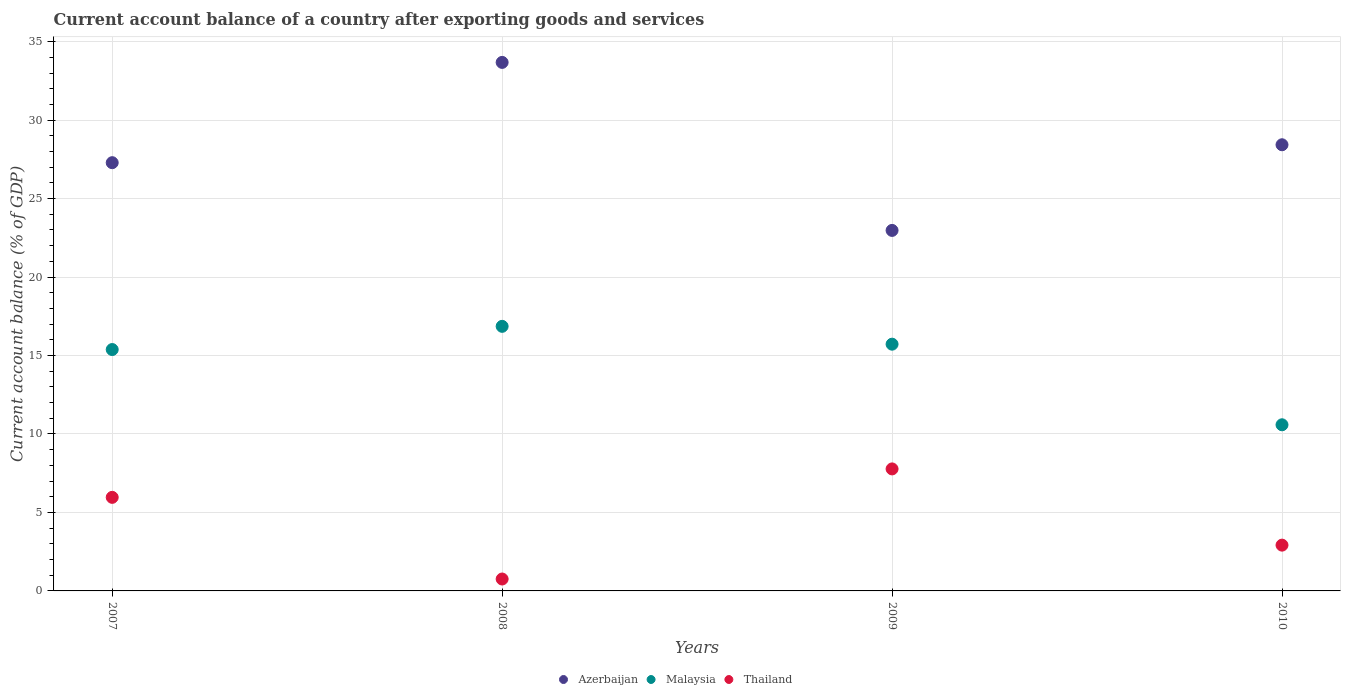How many different coloured dotlines are there?
Offer a very short reply. 3. What is the account balance in Malaysia in 2009?
Your answer should be compact. 15.72. Across all years, what is the maximum account balance in Malaysia?
Offer a terse response. 16.86. Across all years, what is the minimum account balance in Azerbaijan?
Offer a terse response. 22.97. In which year was the account balance in Malaysia maximum?
Provide a short and direct response. 2008. In which year was the account balance in Thailand minimum?
Offer a terse response. 2008. What is the total account balance in Thailand in the graph?
Give a very brief answer. 17.41. What is the difference between the account balance in Azerbaijan in 2008 and that in 2009?
Provide a succinct answer. 10.71. What is the difference between the account balance in Thailand in 2010 and the account balance in Malaysia in 2009?
Provide a succinct answer. -12.81. What is the average account balance in Thailand per year?
Your answer should be compact. 4.35. In the year 2009, what is the difference between the account balance in Thailand and account balance in Malaysia?
Ensure brevity in your answer.  -7.95. In how many years, is the account balance in Azerbaijan greater than 10 %?
Give a very brief answer. 4. What is the ratio of the account balance in Thailand in 2007 to that in 2009?
Your response must be concise. 0.77. Is the account balance in Thailand in 2008 less than that in 2010?
Make the answer very short. Yes. Is the difference between the account balance in Thailand in 2007 and 2010 greater than the difference between the account balance in Malaysia in 2007 and 2010?
Your answer should be very brief. No. What is the difference between the highest and the second highest account balance in Azerbaijan?
Offer a very short reply. 5.25. What is the difference between the highest and the lowest account balance in Azerbaijan?
Provide a succinct answer. 10.71. In how many years, is the account balance in Thailand greater than the average account balance in Thailand taken over all years?
Your answer should be compact. 2. Is the sum of the account balance in Thailand in 2007 and 2008 greater than the maximum account balance in Malaysia across all years?
Keep it short and to the point. No. Is the account balance in Azerbaijan strictly greater than the account balance in Thailand over the years?
Make the answer very short. Yes. Is the account balance in Malaysia strictly less than the account balance in Azerbaijan over the years?
Keep it short and to the point. Yes. How many years are there in the graph?
Make the answer very short. 4. What is the difference between two consecutive major ticks on the Y-axis?
Keep it short and to the point. 5. Are the values on the major ticks of Y-axis written in scientific E-notation?
Your answer should be compact. No. Does the graph contain any zero values?
Keep it short and to the point. No. How many legend labels are there?
Your response must be concise. 3. How are the legend labels stacked?
Make the answer very short. Horizontal. What is the title of the graph?
Make the answer very short. Current account balance of a country after exporting goods and services. Does "Sweden" appear as one of the legend labels in the graph?
Make the answer very short. No. What is the label or title of the Y-axis?
Your answer should be compact. Current account balance (% of GDP). What is the Current account balance (% of GDP) of Azerbaijan in 2007?
Your response must be concise. 27.29. What is the Current account balance (% of GDP) in Malaysia in 2007?
Offer a very short reply. 15.38. What is the Current account balance (% of GDP) of Thailand in 2007?
Make the answer very short. 5.96. What is the Current account balance (% of GDP) in Azerbaijan in 2008?
Provide a short and direct response. 33.68. What is the Current account balance (% of GDP) in Malaysia in 2008?
Ensure brevity in your answer.  16.86. What is the Current account balance (% of GDP) in Thailand in 2008?
Your answer should be compact. 0.76. What is the Current account balance (% of GDP) of Azerbaijan in 2009?
Make the answer very short. 22.97. What is the Current account balance (% of GDP) in Malaysia in 2009?
Your answer should be very brief. 15.72. What is the Current account balance (% of GDP) in Thailand in 2009?
Offer a very short reply. 7.77. What is the Current account balance (% of GDP) of Azerbaijan in 2010?
Your response must be concise. 28.43. What is the Current account balance (% of GDP) of Malaysia in 2010?
Ensure brevity in your answer.  10.59. What is the Current account balance (% of GDP) in Thailand in 2010?
Keep it short and to the point. 2.92. Across all years, what is the maximum Current account balance (% of GDP) of Azerbaijan?
Keep it short and to the point. 33.68. Across all years, what is the maximum Current account balance (% of GDP) in Malaysia?
Your answer should be very brief. 16.86. Across all years, what is the maximum Current account balance (% of GDP) in Thailand?
Make the answer very short. 7.77. Across all years, what is the minimum Current account balance (% of GDP) in Azerbaijan?
Your answer should be compact. 22.97. Across all years, what is the minimum Current account balance (% of GDP) in Malaysia?
Provide a succinct answer. 10.59. Across all years, what is the minimum Current account balance (% of GDP) of Thailand?
Provide a succinct answer. 0.76. What is the total Current account balance (% of GDP) of Azerbaijan in the graph?
Make the answer very short. 112.37. What is the total Current account balance (% of GDP) of Malaysia in the graph?
Your response must be concise. 58.55. What is the total Current account balance (% of GDP) in Thailand in the graph?
Make the answer very short. 17.41. What is the difference between the Current account balance (% of GDP) of Azerbaijan in 2007 and that in 2008?
Keep it short and to the point. -6.39. What is the difference between the Current account balance (% of GDP) of Malaysia in 2007 and that in 2008?
Give a very brief answer. -1.48. What is the difference between the Current account balance (% of GDP) of Thailand in 2007 and that in 2008?
Make the answer very short. 5.2. What is the difference between the Current account balance (% of GDP) of Azerbaijan in 2007 and that in 2009?
Ensure brevity in your answer.  4.32. What is the difference between the Current account balance (% of GDP) in Malaysia in 2007 and that in 2009?
Ensure brevity in your answer.  -0.34. What is the difference between the Current account balance (% of GDP) in Thailand in 2007 and that in 2009?
Ensure brevity in your answer.  -1.81. What is the difference between the Current account balance (% of GDP) in Azerbaijan in 2007 and that in 2010?
Provide a short and direct response. -1.14. What is the difference between the Current account balance (% of GDP) in Malaysia in 2007 and that in 2010?
Provide a succinct answer. 4.79. What is the difference between the Current account balance (% of GDP) in Thailand in 2007 and that in 2010?
Provide a short and direct response. 3.04. What is the difference between the Current account balance (% of GDP) in Azerbaijan in 2008 and that in 2009?
Your answer should be very brief. 10.71. What is the difference between the Current account balance (% of GDP) in Malaysia in 2008 and that in 2009?
Offer a terse response. 1.14. What is the difference between the Current account balance (% of GDP) in Thailand in 2008 and that in 2009?
Your response must be concise. -7.02. What is the difference between the Current account balance (% of GDP) of Azerbaijan in 2008 and that in 2010?
Keep it short and to the point. 5.25. What is the difference between the Current account balance (% of GDP) in Malaysia in 2008 and that in 2010?
Your answer should be very brief. 6.27. What is the difference between the Current account balance (% of GDP) of Thailand in 2008 and that in 2010?
Offer a very short reply. -2.16. What is the difference between the Current account balance (% of GDP) in Azerbaijan in 2009 and that in 2010?
Provide a succinct answer. -5.46. What is the difference between the Current account balance (% of GDP) in Malaysia in 2009 and that in 2010?
Offer a terse response. 5.14. What is the difference between the Current account balance (% of GDP) of Thailand in 2009 and that in 2010?
Ensure brevity in your answer.  4.86. What is the difference between the Current account balance (% of GDP) of Azerbaijan in 2007 and the Current account balance (% of GDP) of Malaysia in 2008?
Ensure brevity in your answer.  10.43. What is the difference between the Current account balance (% of GDP) of Azerbaijan in 2007 and the Current account balance (% of GDP) of Thailand in 2008?
Your response must be concise. 26.53. What is the difference between the Current account balance (% of GDP) in Malaysia in 2007 and the Current account balance (% of GDP) in Thailand in 2008?
Make the answer very short. 14.62. What is the difference between the Current account balance (% of GDP) of Azerbaijan in 2007 and the Current account balance (% of GDP) of Malaysia in 2009?
Provide a succinct answer. 11.57. What is the difference between the Current account balance (% of GDP) in Azerbaijan in 2007 and the Current account balance (% of GDP) in Thailand in 2009?
Make the answer very short. 19.51. What is the difference between the Current account balance (% of GDP) in Malaysia in 2007 and the Current account balance (% of GDP) in Thailand in 2009?
Offer a terse response. 7.61. What is the difference between the Current account balance (% of GDP) of Azerbaijan in 2007 and the Current account balance (% of GDP) of Malaysia in 2010?
Provide a short and direct response. 16.7. What is the difference between the Current account balance (% of GDP) of Azerbaijan in 2007 and the Current account balance (% of GDP) of Thailand in 2010?
Your answer should be compact. 24.37. What is the difference between the Current account balance (% of GDP) of Malaysia in 2007 and the Current account balance (% of GDP) of Thailand in 2010?
Offer a very short reply. 12.46. What is the difference between the Current account balance (% of GDP) of Azerbaijan in 2008 and the Current account balance (% of GDP) of Malaysia in 2009?
Your answer should be compact. 17.96. What is the difference between the Current account balance (% of GDP) of Azerbaijan in 2008 and the Current account balance (% of GDP) of Thailand in 2009?
Keep it short and to the point. 25.9. What is the difference between the Current account balance (% of GDP) in Malaysia in 2008 and the Current account balance (% of GDP) in Thailand in 2009?
Offer a very short reply. 9.09. What is the difference between the Current account balance (% of GDP) in Azerbaijan in 2008 and the Current account balance (% of GDP) in Malaysia in 2010?
Give a very brief answer. 23.09. What is the difference between the Current account balance (% of GDP) in Azerbaijan in 2008 and the Current account balance (% of GDP) in Thailand in 2010?
Offer a terse response. 30.76. What is the difference between the Current account balance (% of GDP) of Malaysia in 2008 and the Current account balance (% of GDP) of Thailand in 2010?
Your response must be concise. 13.94. What is the difference between the Current account balance (% of GDP) in Azerbaijan in 2009 and the Current account balance (% of GDP) in Malaysia in 2010?
Provide a short and direct response. 12.39. What is the difference between the Current account balance (% of GDP) of Azerbaijan in 2009 and the Current account balance (% of GDP) of Thailand in 2010?
Provide a succinct answer. 20.06. What is the difference between the Current account balance (% of GDP) in Malaysia in 2009 and the Current account balance (% of GDP) in Thailand in 2010?
Offer a very short reply. 12.81. What is the average Current account balance (% of GDP) in Azerbaijan per year?
Provide a short and direct response. 28.09. What is the average Current account balance (% of GDP) in Malaysia per year?
Make the answer very short. 14.64. What is the average Current account balance (% of GDP) in Thailand per year?
Your answer should be compact. 4.35. In the year 2007, what is the difference between the Current account balance (% of GDP) in Azerbaijan and Current account balance (% of GDP) in Malaysia?
Your answer should be compact. 11.91. In the year 2007, what is the difference between the Current account balance (% of GDP) in Azerbaijan and Current account balance (% of GDP) in Thailand?
Give a very brief answer. 21.33. In the year 2007, what is the difference between the Current account balance (% of GDP) of Malaysia and Current account balance (% of GDP) of Thailand?
Make the answer very short. 9.42. In the year 2008, what is the difference between the Current account balance (% of GDP) in Azerbaijan and Current account balance (% of GDP) in Malaysia?
Provide a short and direct response. 16.82. In the year 2008, what is the difference between the Current account balance (% of GDP) of Azerbaijan and Current account balance (% of GDP) of Thailand?
Your answer should be compact. 32.92. In the year 2008, what is the difference between the Current account balance (% of GDP) in Malaysia and Current account balance (% of GDP) in Thailand?
Make the answer very short. 16.1. In the year 2009, what is the difference between the Current account balance (% of GDP) of Azerbaijan and Current account balance (% of GDP) of Malaysia?
Provide a succinct answer. 7.25. In the year 2009, what is the difference between the Current account balance (% of GDP) of Azerbaijan and Current account balance (% of GDP) of Thailand?
Offer a terse response. 15.2. In the year 2009, what is the difference between the Current account balance (% of GDP) of Malaysia and Current account balance (% of GDP) of Thailand?
Make the answer very short. 7.95. In the year 2010, what is the difference between the Current account balance (% of GDP) in Azerbaijan and Current account balance (% of GDP) in Malaysia?
Ensure brevity in your answer.  17.84. In the year 2010, what is the difference between the Current account balance (% of GDP) of Azerbaijan and Current account balance (% of GDP) of Thailand?
Make the answer very short. 25.51. In the year 2010, what is the difference between the Current account balance (% of GDP) of Malaysia and Current account balance (% of GDP) of Thailand?
Give a very brief answer. 7.67. What is the ratio of the Current account balance (% of GDP) of Azerbaijan in 2007 to that in 2008?
Ensure brevity in your answer.  0.81. What is the ratio of the Current account balance (% of GDP) in Malaysia in 2007 to that in 2008?
Your response must be concise. 0.91. What is the ratio of the Current account balance (% of GDP) in Thailand in 2007 to that in 2008?
Your answer should be compact. 7.86. What is the ratio of the Current account balance (% of GDP) of Azerbaijan in 2007 to that in 2009?
Offer a very short reply. 1.19. What is the ratio of the Current account balance (% of GDP) of Malaysia in 2007 to that in 2009?
Provide a succinct answer. 0.98. What is the ratio of the Current account balance (% of GDP) of Thailand in 2007 to that in 2009?
Keep it short and to the point. 0.77. What is the ratio of the Current account balance (% of GDP) of Azerbaijan in 2007 to that in 2010?
Offer a terse response. 0.96. What is the ratio of the Current account balance (% of GDP) of Malaysia in 2007 to that in 2010?
Keep it short and to the point. 1.45. What is the ratio of the Current account balance (% of GDP) in Thailand in 2007 to that in 2010?
Provide a short and direct response. 2.04. What is the ratio of the Current account balance (% of GDP) of Azerbaijan in 2008 to that in 2009?
Your answer should be very brief. 1.47. What is the ratio of the Current account balance (% of GDP) in Malaysia in 2008 to that in 2009?
Your answer should be compact. 1.07. What is the ratio of the Current account balance (% of GDP) of Thailand in 2008 to that in 2009?
Offer a very short reply. 0.1. What is the ratio of the Current account balance (% of GDP) of Azerbaijan in 2008 to that in 2010?
Make the answer very short. 1.18. What is the ratio of the Current account balance (% of GDP) in Malaysia in 2008 to that in 2010?
Ensure brevity in your answer.  1.59. What is the ratio of the Current account balance (% of GDP) in Thailand in 2008 to that in 2010?
Provide a succinct answer. 0.26. What is the ratio of the Current account balance (% of GDP) of Azerbaijan in 2009 to that in 2010?
Offer a very short reply. 0.81. What is the ratio of the Current account balance (% of GDP) in Malaysia in 2009 to that in 2010?
Your answer should be compact. 1.49. What is the ratio of the Current account balance (% of GDP) of Thailand in 2009 to that in 2010?
Provide a short and direct response. 2.66. What is the difference between the highest and the second highest Current account balance (% of GDP) in Azerbaijan?
Your answer should be compact. 5.25. What is the difference between the highest and the second highest Current account balance (% of GDP) in Malaysia?
Provide a short and direct response. 1.14. What is the difference between the highest and the second highest Current account balance (% of GDP) of Thailand?
Provide a short and direct response. 1.81. What is the difference between the highest and the lowest Current account balance (% of GDP) in Azerbaijan?
Provide a succinct answer. 10.71. What is the difference between the highest and the lowest Current account balance (% of GDP) in Malaysia?
Offer a very short reply. 6.27. What is the difference between the highest and the lowest Current account balance (% of GDP) in Thailand?
Your response must be concise. 7.02. 